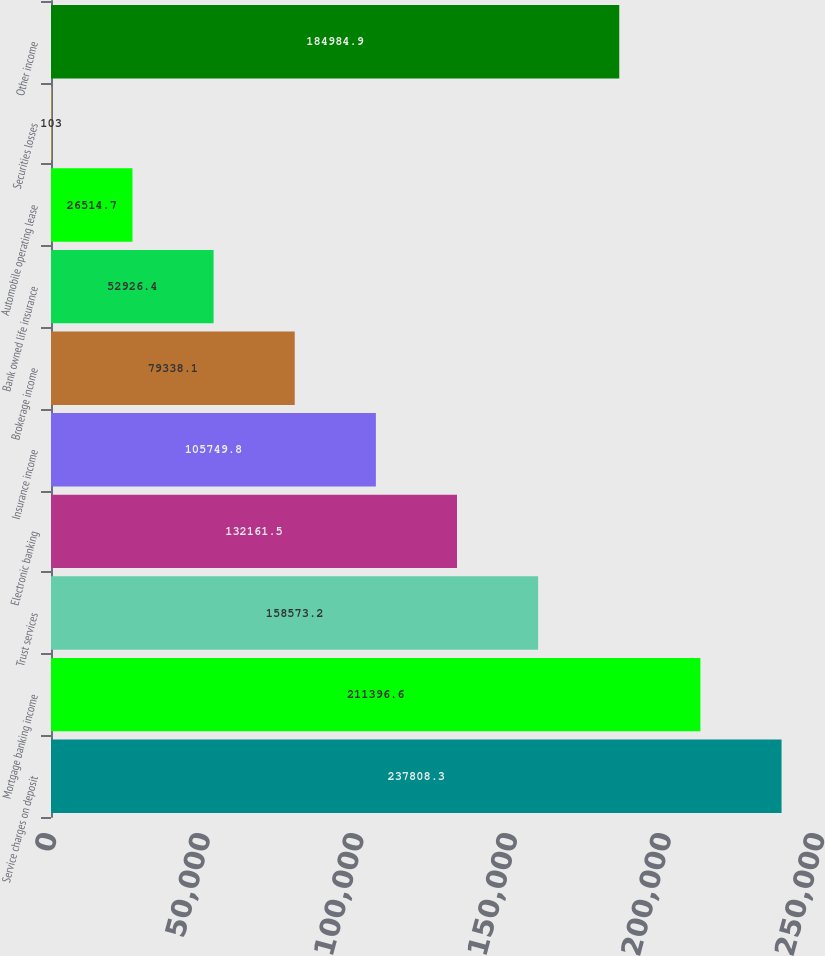Convert chart. <chart><loc_0><loc_0><loc_500><loc_500><bar_chart><fcel>Service charges on deposit<fcel>Mortgage banking income<fcel>Trust services<fcel>Electronic banking<fcel>Insurance income<fcel>Brokerage income<fcel>Bank owned life insurance<fcel>Automobile operating lease<fcel>Securities losses<fcel>Other income<nl><fcel>237808<fcel>211397<fcel>158573<fcel>132162<fcel>105750<fcel>79338.1<fcel>52926.4<fcel>26514.7<fcel>103<fcel>184985<nl></chart> 